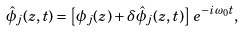<formula> <loc_0><loc_0><loc_500><loc_500>\hat { \phi } _ { j } ( z , t ) = \left [ \phi _ { j } ( z ) + \delta \hat { \phi } _ { j } ( z , t ) \right ] \, e ^ { - i \omega _ { 0 } t } ,</formula> 